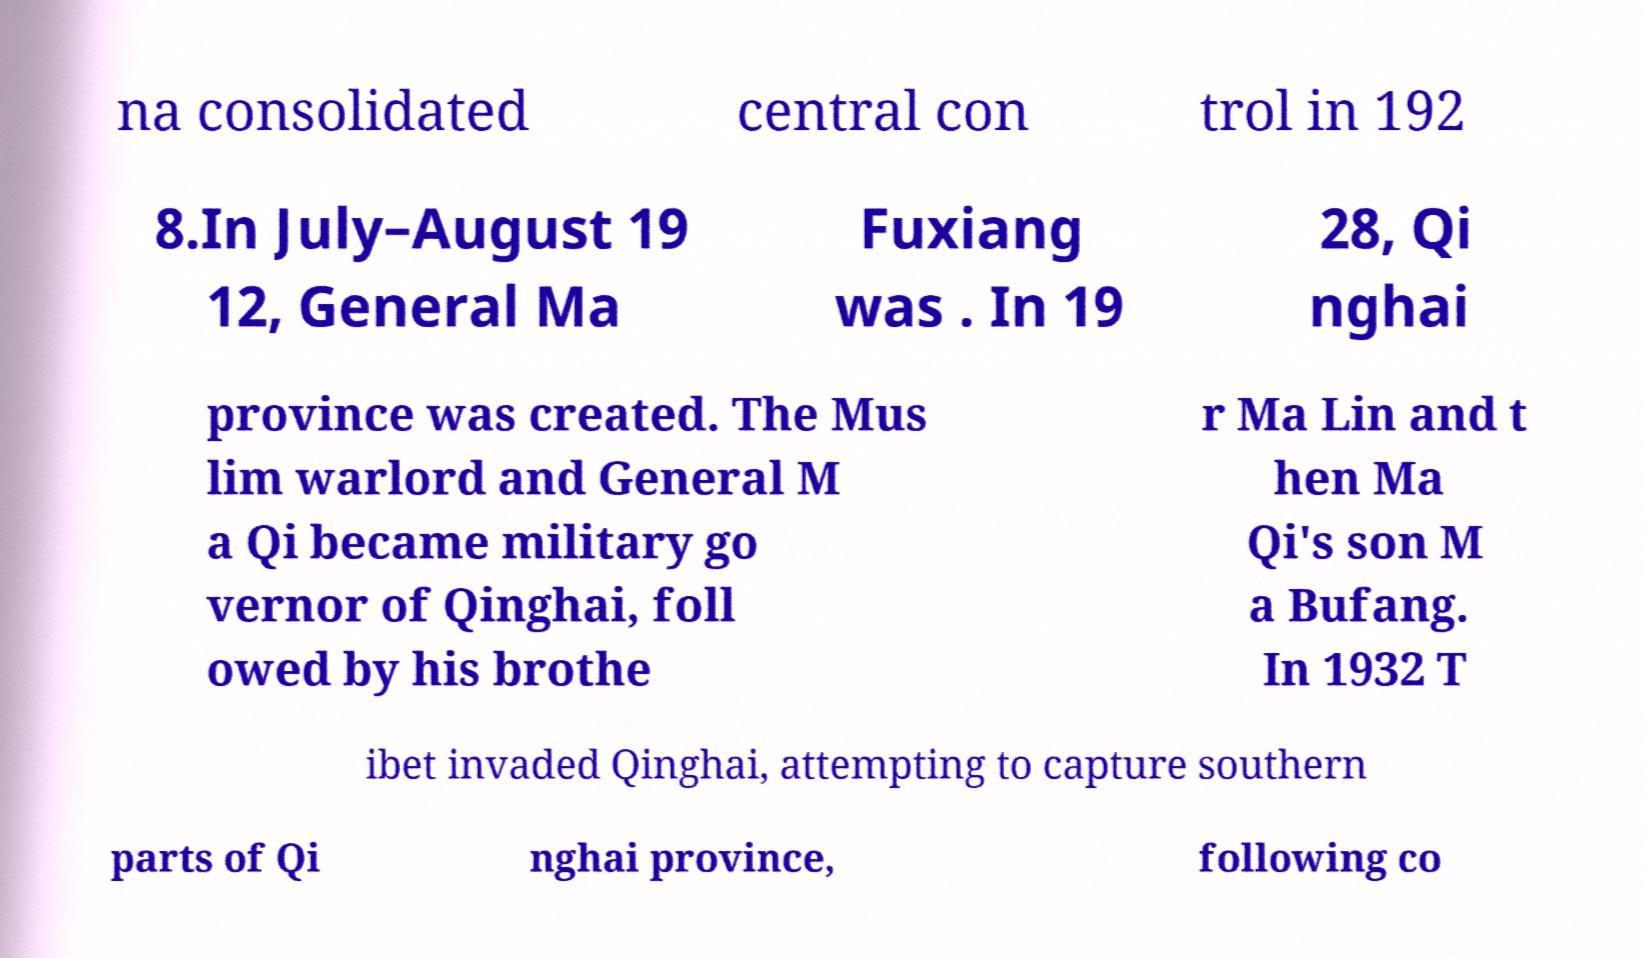There's text embedded in this image that I need extracted. Can you transcribe it verbatim? na consolidated central con trol in 192 8.In July–August 19 12, General Ma Fuxiang was . In 19 28, Qi nghai province was created. The Mus lim warlord and General M a Qi became military go vernor of Qinghai, foll owed by his brothe r Ma Lin and t hen Ma Qi's son M a Bufang. In 1932 T ibet invaded Qinghai, attempting to capture southern parts of Qi nghai province, following co 